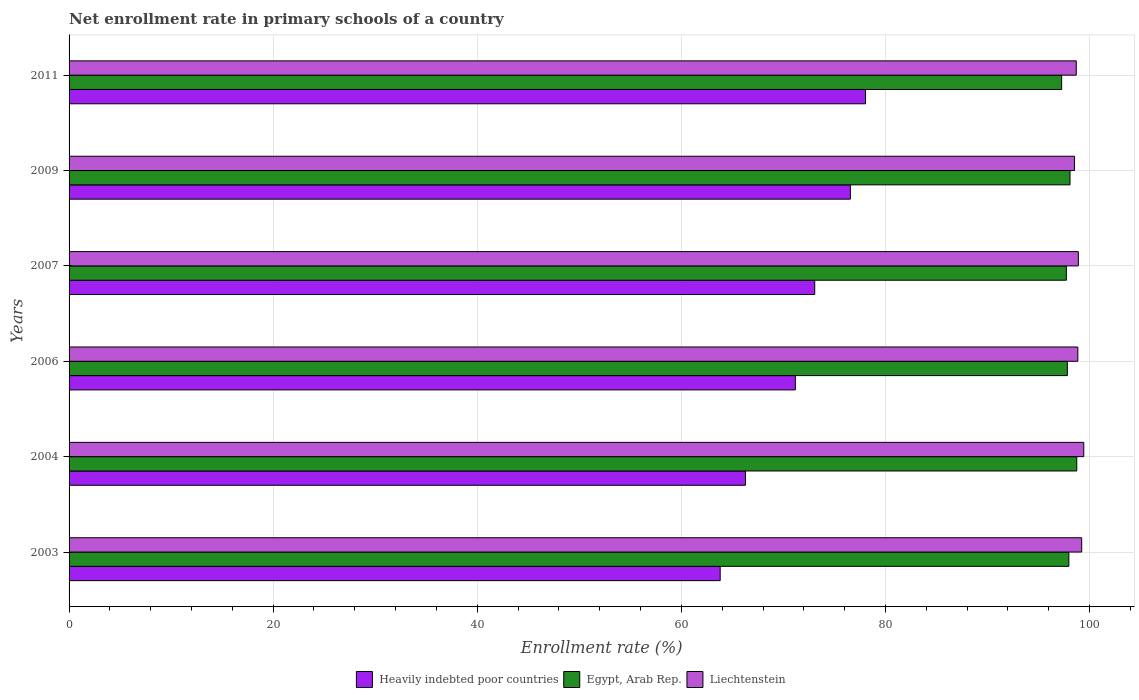How many groups of bars are there?
Your answer should be very brief. 6. How many bars are there on the 1st tick from the top?
Your response must be concise. 3. What is the label of the 6th group of bars from the top?
Offer a very short reply. 2003. What is the enrollment rate in primary schools in Egypt, Arab Rep. in 2007?
Your response must be concise. 97.73. Across all years, what is the maximum enrollment rate in primary schools in Egypt, Arab Rep.?
Keep it short and to the point. 98.75. Across all years, what is the minimum enrollment rate in primary schools in Liechtenstein?
Your answer should be very brief. 98.52. What is the total enrollment rate in primary schools in Liechtenstein in the graph?
Offer a very short reply. 593.63. What is the difference between the enrollment rate in primary schools in Liechtenstein in 2003 and that in 2009?
Your answer should be very brief. 0.71. What is the difference between the enrollment rate in primary schools in Liechtenstein in 2007 and the enrollment rate in primary schools in Heavily indebted poor countries in 2003?
Offer a very short reply. 35.1. What is the average enrollment rate in primary schools in Liechtenstein per year?
Offer a terse response. 98.94. In the year 2003, what is the difference between the enrollment rate in primary schools in Heavily indebted poor countries and enrollment rate in primary schools in Liechtenstein?
Make the answer very short. -35.42. What is the ratio of the enrollment rate in primary schools in Egypt, Arab Rep. in 2006 to that in 2011?
Make the answer very short. 1.01. Is the enrollment rate in primary schools in Heavily indebted poor countries in 2003 less than that in 2011?
Offer a terse response. Yes. What is the difference between the highest and the second highest enrollment rate in primary schools in Liechtenstein?
Keep it short and to the point. 0.2. What is the difference between the highest and the lowest enrollment rate in primary schools in Liechtenstein?
Provide a short and direct response. 0.91. In how many years, is the enrollment rate in primary schools in Egypt, Arab Rep. greater than the average enrollment rate in primary schools in Egypt, Arab Rep. taken over all years?
Make the answer very short. 3. Is the sum of the enrollment rate in primary schools in Liechtenstein in 2004 and 2007 greater than the maximum enrollment rate in primary schools in Egypt, Arab Rep. across all years?
Offer a very short reply. Yes. What does the 2nd bar from the top in 2009 represents?
Give a very brief answer. Egypt, Arab Rep. What does the 1st bar from the bottom in 2009 represents?
Keep it short and to the point. Heavily indebted poor countries. Is it the case that in every year, the sum of the enrollment rate in primary schools in Heavily indebted poor countries and enrollment rate in primary schools in Egypt, Arab Rep. is greater than the enrollment rate in primary schools in Liechtenstein?
Offer a terse response. Yes. How many bars are there?
Your answer should be compact. 18. How many years are there in the graph?
Provide a succinct answer. 6. What is the difference between two consecutive major ticks on the X-axis?
Your answer should be compact. 20. Are the values on the major ticks of X-axis written in scientific E-notation?
Your response must be concise. No. Does the graph contain any zero values?
Offer a very short reply. No. Where does the legend appear in the graph?
Your answer should be compact. Bottom center. How many legend labels are there?
Provide a short and direct response. 3. How are the legend labels stacked?
Your response must be concise. Horizontal. What is the title of the graph?
Offer a terse response. Net enrollment rate in primary schools of a country. Does "Latin America(developing only)" appear as one of the legend labels in the graph?
Make the answer very short. No. What is the label or title of the X-axis?
Ensure brevity in your answer.  Enrollment rate (%). What is the Enrollment rate (%) in Heavily indebted poor countries in 2003?
Offer a very short reply. 63.81. What is the Enrollment rate (%) in Egypt, Arab Rep. in 2003?
Offer a terse response. 97.97. What is the Enrollment rate (%) in Liechtenstein in 2003?
Provide a succinct answer. 99.23. What is the Enrollment rate (%) of Heavily indebted poor countries in 2004?
Offer a very short reply. 66.28. What is the Enrollment rate (%) in Egypt, Arab Rep. in 2004?
Offer a terse response. 98.75. What is the Enrollment rate (%) in Liechtenstein in 2004?
Provide a short and direct response. 99.43. What is the Enrollment rate (%) in Heavily indebted poor countries in 2006?
Offer a terse response. 71.17. What is the Enrollment rate (%) in Egypt, Arab Rep. in 2006?
Offer a terse response. 97.83. What is the Enrollment rate (%) of Liechtenstein in 2006?
Ensure brevity in your answer.  98.85. What is the Enrollment rate (%) in Heavily indebted poor countries in 2007?
Give a very brief answer. 73.07. What is the Enrollment rate (%) of Egypt, Arab Rep. in 2007?
Ensure brevity in your answer.  97.73. What is the Enrollment rate (%) in Liechtenstein in 2007?
Offer a terse response. 98.9. What is the Enrollment rate (%) of Heavily indebted poor countries in 2009?
Make the answer very short. 76.56. What is the Enrollment rate (%) of Egypt, Arab Rep. in 2009?
Provide a succinct answer. 98.09. What is the Enrollment rate (%) of Liechtenstein in 2009?
Ensure brevity in your answer.  98.52. What is the Enrollment rate (%) of Heavily indebted poor countries in 2011?
Offer a terse response. 78.05. What is the Enrollment rate (%) in Egypt, Arab Rep. in 2011?
Offer a terse response. 97.27. What is the Enrollment rate (%) in Liechtenstein in 2011?
Ensure brevity in your answer.  98.7. Across all years, what is the maximum Enrollment rate (%) of Heavily indebted poor countries?
Offer a very short reply. 78.05. Across all years, what is the maximum Enrollment rate (%) of Egypt, Arab Rep.?
Give a very brief answer. 98.75. Across all years, what is the maximum Enrollment rate (%) of Liechtenstein?
Provide a short and direct response. 99.43. Across all years, what is the minimum Enrollment rate (%) in Heavily indebted poor countries?
Your response must be concise. 63.81. Across all years, what is the minimum Enrollment rate (%) of Egypt, Arab Rep.?
Give a very brief answer. 97.27. Across all years, what is the minimum Enrollment rate (%) of Liechtenstein?
Your answer should be compact. 98.52. What is the total Enrollment rate (%) in Heavily indebted poor countries in the graph?
Your response must be concise. 428.93. What is the total Enrollment rate (%) of Egypt, Arab Rep. in the graph?
Your answer should be very brief. 587.62. What is the total Enrollment rate (%) in Liechtenstein in the graph?
Provide a succinct answer. 593.63. What is the difference between the Enrollment rate (%) in Heavily indebted poor countries in 2003 and that in 2004?
Your answer should be very brief. -2.48. What is the difference between the Enrollment rate (%) in Egypt, Arab Rep. in 2003 and that in 2004?
Provide a short and direct response. -0.78. What is the difference between the Enrollment rate (%) in Liechtenstein in 2003 and that in 2004?
Provide a succinct answer. -0.2. What is the difference between the Enrollment rate (%) in Heavily indebted poor countries in 2003 and that in 2006?
Give a very brief answer. -7.37. What is the difference between the Enrollment rate (%) in Egypt, Arab Rep. in 2003 and that in 2006?
Your answer should be compact. 0.15. What is the difference between the Enrollment rate (%) in Liechtenstein in 2003 and that in 2006?
Offer a terse response. 0.38. What is the difference between the Enrollment rate (%) of Heavily indebted poor countries in 2003 and that in 2007?
Offer a very short reply. -9.27. What is the difference between the Enrollment rate (%) of Egypt, Arab Rep. in 2003 and that in 2007?
Provide a succinct answer. 0.24. What is the difference between the Enrollment rate (%) of Liechtenstein in 2003 and that in 2007?
Your answer should be very brief. 0.33. What is the difference between the Enrollment rate (%) of Heavily indebted poor countries in 2003 and that in 2009?
Make the answer very short. -12.76. What is the difference between the Enrollment rate (%) in Egypt, Arab Rep. in 2003 and that in 2009?
Your answer should be compact. -0.11. What is the difference between the Enrollment rate (%) in Liechtenstein in 2003 and that in 2009?
Offer a terse response. 0.71. What is the difference between the Enrollment rate (%) of Heavily indebted poor countries in 2003 and that in 2011?
Offer a very short reply. -14.24. What is the difference between the Enrollment rate (%) in Egypt, Arab Rep. in 2003 and that in 2011?
Provide a succinct answer. 0.71. What is the difference between the Enrollment rate (%) in Liechtenstein in 2003 and that in 2011?
Offer a terse response. 0.53. What is the difference between the Enrollment rate (%) of Heavily indebted poor countries in 2004 and that in 2006?
Your response must be concise. -4.89. What is the difference between the Enrollment rate (%) of Egypt, Arab Rep. in 2004 and that in 2006?
Make the answer very short. 0.92. What is the difference between the Enrollment rate (%) of Liechtenstein in 2004 and that in 2006?
Your answer should be very brief. 0.58. What is the difference between the Enrollment rate (%) of Heavily indebted poor countries in 2004 and that in 2007?
Offer a terse response. -6.79. What is the difference between the Enrollment rate (%) in Egypt, Arab Rep. in 2004 and that in 2007?
Ensure brevity in your answer.  1.02. What is the difference between the Enrollment rate (%) of Liechtenstein in 2004 and that in 2007?
Give a very brief answer. 0.53. What is the difference between the Enrollment rate (%) in Heavily indebted poor countries in 2004 and that in 2009?
Make the answer very short. -10.28. What is the difference between the Enrollment rate (%) in Egypt, Arab Rep. in 2004 and that in 2009?
Your answer should be compact. 0.66. What is the difference between the Enrollment rate (%) of Liechtenstein in 2004 and that in 2009?
Keep it short and to the point. 0.91. What is the difference between the Enrollment rate (%) in Heavily indebted poor countries in 2004 and that in 2011?
Offer a very short reply. -11.77. What is the difference between the Enrollment rate (%) of Egypt, Arab Rep. in 2004 and that in 2011?
Ensure brevity in your answer.  1.48. What is the difference between the Enrollment rate (%) in Liechtenstein in 2004 and that in 2011?
Give a very brief answer. 0.73. What is the difference between the Enrollment rate (%) of Heavily indebted poor countries in 2006 and that in 2007?
Give a very brief answer. -1.9. What is the difference between the Enrollment rate (%) in Egypt, Arab Rep. in 2006 and that in 2007?
Make the answer very short. 0.1. What is the difference between the Enrollment rate (%) in Liechtenstein in 2006 and that in 2007?
Give a very brief answer. -0.05. What is the difference between the Enrollment rate (%) of Heavily indebted poor countries in 2006 and that in 2009?
Provide a succinct answer. -5.39. What is the difference between the Enrollment rate (%) of Egypt, Arab Rep. in 2006 and that in 2009?
Your answer should be compact. -0.26. What is the difference between the Enrollment rate (%) in Liechtenstein in 2006 and that in 2009?
Offer a terse response. 0.33. What is the difference between the Enrollment rate (%) in Heavily indebted poor countries in 2006 and that in 2011?
Your answer should be compact. -6.87. What is the difference between the Enrollment rate (%) of Egypt, Arab Rep. in 2006 and that in 2011?
Provide a succinct answer. 0.56. What is the difference between the Enrollment rate (%) in Liechtenstein in 2006 and that in 2011?
Your answer should be very brief. 0.15. What is the difference between the Enrollment rate (%) of Heavily indebted poor countries in 2007 and that in 2009?
Provide a succinct answer. -3.49. What is the difference between the Enrollment rate (%) of Egypt, Arab Rep. in 2007 and that in 2009?
Offer a terse response. -0.36. What is the difference between the Enrollment rate (%) of Liechtenstein in 2007 and that in 2009?
Your response must be concise. 0.38. What is the difference between the Enrollment rate (%) in Heavily indebted poor countries in 2007 and that in 2011?
Give a very brief answer. -4.98. What is the difference between the Enrollment rate (%) in Egypt, Arab Rep. in 2007 and that in 2011?
Ensure brevity in your answer.  0.46. What is the difference between the Enrollment rate (%) of Liechtenstein in 2007 and that in 2011?
Provide a short and direct response. 0.2. What is the difference between the Enrollment rate (%) in Heavily indebted poor countries in 2009 and that in 2011?
Keep it short and to the point. -1.48. What is the difference between the Enrollment rate (%) of Egypt, Arab Rep. in 2009 and that in 2011?
Your answer should be very brief. 0.82. What is the difference between the Enrollment rate (%) in Liechtenstein in 2009 and that in 2011?
Offer a very short reply. -0.18. What is the difference between the Enrollment rate (%) in Heavily indebted poor countries in 2003 and the Enrollment rate (%) in Egypt, Arab Rep. in 2004?
Offer a terse response. -34.94. What is the difference between the Enrollment rate (%) of Heavily indebted poor countries in 2003 and the Enrollment rate (%) of Liechtenstein in 2004?
Your answer should be very brief. -35.63. What is the difference between the Enrollment rate (%) in Egypt, Arab Rep. in 2003 and the Enrollment rate (%) in Liechtenstein in 2004?
Provide a succinct answer. -1.46. What is the difference between the Enrollment rate (%) of Heavily indebted poor countries in 2003 and the Enrollment rate (%) of Egypt, Arab Rep. in 2006?
Make the answer very short. -34.02. What is the difference between the Enrollment rate (%) of Heavily indebted poor countries in 2003 and the Enrollment rate (%) of Liechtenstein in 2006?
Keep it short and to the point. -35.05. What is the difference between the Enrollment rate (%) of Egypt, Arab Rep. in 2003 and the Enrollment rate (%) of Liechtenstein in 2006?
Your answer should be compact. -0.88. What is the difference between the Enrollment rate (%) of Heavily indebted poor countries in 2003 and the Enrollment rate (%) of Egypt, Arab Rep. in 2007?
Your response must be concise. -33.92. What is the difference between the Enrollment rate (%) of Heavily indebted poor countries in 2003 and the Enrollment rate (%) of Liechtenstein in 2007?
Ensure brevity in your answer.  -35.1. What is the difference between the Enrollment rate (%) in Egypt, Arab Rep. in 2003 and the Enrollment rate (%) in Liechtenstein in 2007?
Make the answer very short. -0.93. What is the difference between the Enrollment rate (%) of Heavily indebted poor countries in 2003 and the Enrollment rate (%) of Egypt, Arab Rep. in 2009?
Keep it short and to the point. -34.28. What is the difference between the Enrollment rate (%) in Heavily indebted poor countries in 2003 and the Enrollment rate (%) in Liechtenstein in 2009?
Your response must be concise. -34.72. What is the difference between the Enrollment rate (%) in Egypt, Arab Rep. in 2003 and the Enrollment rate (%) in Liechtenstein in 2009?
Provide a short and direct response. -0.55. What is the difference between the Enrollment rate (%) of Heavily indebted poor countries in 2003 and the Enrollment rate (%) of Egypt, Arab Rep. in 2011?
Offer a very short reply. -33.46. What is the difference between the Enrollment rate (%) in Heavily indebted poor countries in 2003 and the Enrollment rate (%) in Liechtenstein in 2011?
Your response must be concise. -34.89. What is the difference between the Enrollment rate (%) in Egypt, Arab Rep. in 2003 and the Enrollment rate (%) in Liechtenstein in 2011?
Your response must be concise. -0.73. What is the difference between the Enrollment rate (%) of Heavily indebted poor countries in 2004 and the Enrollment rate (%) of Egypt, Arab Rep. in 2006?
Your answer should be very brief. -31.54. What is the difference between the Enrollment rate (%) of Heavily indebted poor countries in 2004 and the Enrollment rate (%) of Liechtenstein in 2006?
Keep it short and to the point. -32.57. What is the difference between the Enrollment rate (%) of Egypt, Arab Rep. in 2004 and the Enrollment rate (%) of Liechtenstein in 2006?
Provide a succinct answer. -0.1. What is the difference between the Enrollment rate (%) in Heavily indebted poor countries in 2004 and the Enrollment rate (%) in Egypt, Arab Rep. in 2007?
Keep it short and to the point. -31.45. What is the difference between the Enrollment rate (%) in Heavily indebted poor countries in 2004 and the Enrollment rate (%) in Liechtenstein in 2007?
Make the answer very short. -32.62. What is the difference between the Enrollment rate (%) of Egypt, Arab Rep. in 2004 and the Enrollment rate (%) of Liechtenstein in 2007?
Offer a very short reply. -0.15. What is the difference between the Enrollment rate (%) of Heavily indebted poor countries in 2004 and the Enrollment rate (%) of Egypt, Arab Rep. in 2009?
Ensure brevity in your answer.  -31.8. What is the difference between the Enrollment rate (%) in Heavily indebted poor countries in 2004 and the Enrollment rate (%) in Liechtenstein in 2009?
Make the answer very short. -32.24. What is the difference between the Enrollment rate (%) of Egypt, Arab Rep. in 2004 and the Enrollment rate (%) of Liechtenstein in 2009?
Your response must be concise. 0.23. What is the difference between the Enrollment rate (%) in Heavily indebted poor countries in 2004 and the Enrollment rate (%) in Egypt, Arab Rep. in 2011?
Your response must be concise. -30.99. What is the difference between the Enrollment rate (%) in Heavily indebted poor countries in 2004 and the Enrollment rate (%) in Liechtenstein in 2011?
Offer a very short reply. -32.42. What is the difference between the Enrollment rate (%) of Egypt, Arab Rep. in 2004 and the Enrollment rate (%) of Liechtenstein in 2011?
Your answer should be very brief. 0.05. What is the difference between the Enrollment rate (%) in Heavily indebted poor countries in 2006 and the Enrollment rate (%) in Egypt, Arab Rep. in 2007?
Make the answer very short. -26.56. What is the difference between the Enrollment rate (%) in Heavily indebted poor countries in 2006 and the Enrollment rate (%) in Liechtenstein in 2007?
Offer a very short reply. -27.73. What is the difference between the Enrollment rate (%) of Egypt, Arab Rep. in 2006 and the Enrollment rate (%) of Liechtenstein in 2007?
Make the answer very short. -1.08. What is the difference between the Enrollment rate (%) in Heavily indebted poor countries in 2006 and the Enrollment rate (%) in Egypt, Arab Rep. in 2009?
Your answer should be very brief. -26.91. What is the difference between the Enrollment rate (%) in Heavily indebted poor countries in 2006 and the Enrollment rate (%) in Liechtenstein in 2009?
Give a very brief answer. -27.35. What is the difference between the Enrollment rate (%) in Egypt, Arab Rep. in 2006 and the Enrollment rate (%) in Liechtenstein in 2009?
Ensure brevity in your answer.  -0.7. What is the difference between the Enrollment rate (%) in Heavily indebted poor countries in 2006 and the Enrollment rate (%) in Egypt, Arab Rep. in 2011?
Your answer should be very brief. -26.1. What is the difference between the Enrollment rate (%) of Heavily indebted poor countries in 2006 and the Enrollment rate (%) of Liechtenstein in 2011?
Offer a very short reply. -27.53. What is the difference between the Enrollment rate (%) of Egypt, Arab Rep. in 2006 and the Enrollment rate (%) of Liechtenstein in 2011?
Provide a short and direct response. -0.87. What is the difference between the Enrollment rate (%) in Heavily indebted poor countries in 2007 and the Enrollment rate (%) in Egypt, Arab Rep. in 2009?
Offer a very short reply. -25.02. What is the difference between the Enrollment rate (%) of Heavily indebted poor countries in 2007 and the Enrollment rate (%) of Liechtenstein in 2009?
Offer a terse response. -25.45. What is the difference between the Enrollment rate (%) of Egypt, Arab Rep. in 2007 and the Enrollment rate (%) of Liechtenstein in 2009?
Offer a very short reply. -0.79. What is the difference between the Enrollment rate (%) in Heavily indebted poor countries in 2007 and the Enrollment rate (%) in Egypt, Arab Rep. in 2011?
Your answer should be compact. -24.2. What is the difference between the Enrollment rate (%) of Heavily indebted poor countries in 2007 and the Enrollment rate (%) of Liechtenstein in 2011?
Your response must be concise. -25.63. What is the difference between the Enrollment rate (%) in Egypt, Arab Rep. in 2007 and the Enrollment rate (%) in Liechtenstein in 2011?
Your answer should be compact. -0.97. What is the difference between the Enrollment rate (%) in Heavily indebted poor countries in 2009 and the Enrollment rate (%) in Egypt, Arab Rep. in 2011?
Offer a very short reply. -20.7. What is the difference between the Enrollment rate (%) in Heavily indebted poor countries in 2009 and the Enrollment rate (%) in Liechtenstein in 2011?
Give a very brief answer. -22.13. What is the difference between the Enrollment rate (%) of Egypt, Arab Rep. in 2009 and the Enrollment rate (%) of Liechtenstein in 2011?
Keep it short and to the point. -0.61. What is the average Enrollment rate (%) of Heavily indebted poor countries per year?
Your answer should be very brief. 71.49. What is the average Enrollment rate (%) in Egypt, Arab Rep. per year?
Offer a very short reply. 97.94. What is the average Enrollment rate (%) of Liechtenstein per year?
Ensure brevity in your answer.  98.94. In the year 2003, what is the difference between the Enrollment rate (%) of Heavily indebted poor countries and Enrollment rate (%) of Egypt, Arab Rep.?
Make the answer very short. -34.17. In the year 2003, what is the difference between the Enrollment rate (%) in Heavily indebted poor countries and Enrollment rate (%) in Liechtenstein?
Give a very brief answer. -35.42. In the year 2003, what is the difference between the Enrollment rate (%) in Egypt, Arab Rep. and Enrollment rate (%) in Liechtenstein?
Your answer should be very brief. -1.26. In the year 2004, what is the difference between the Enrollment rate (%) of Heavily indebted poor countries and Enrollment rate (%) of Egypt, Arab Rep.?
Your answer should be very brief. -32.47. In the year 2004, what is the difference between the Enrollment rate (%) of Heavily indebted poor countries and Enrollment rate (%) of Liechtenstein?
Your answer should be very brief. -33.15. In the year 2004, what is the difference between the Enrollment rate (%) in Egypt, Arab Rep. and Enrollment rate (%) in Liechtenstein?
Your answer should be very brief. -0.68. In the year 2006, what is the difference between the Enrollment rate (%) of Heavily indebted poor countries and Enrollment rate (%) of Egypt, Arab Rep.?
Your answer should be compact. -26.65. In the year 2006, what is the difference between the Enrollment rate (%) in Heavily indebted poor countries and Enrollment rate (%) in Liechtenstein?
Offer a terse response. -27.68. In the year 2006, what is the difference between the Enrollment rate (%) in Egypt, Arab Rep. and Enrollment rate (%) in Liechtenstein?
Your response must be concise. -1.03. In the year 2007, what is the difference between the Enrollment rate (%) of Heavily indebted poor countries and Enrollment rate (%) of Egypt, Arab Rep.?
Ensure brevity in your answer.  -24.66. In the year 2007, what is the difference between the Enrollment rate (%) of Heavily indebted poor countries and Enrollment rate (%) of Liechtenstein?
Your response must be concise. -25.83. In the year 2007, what is the difference between the Enrollment rate (%) of Egypt, Arab Rep. and Enrollment rate (%) of Liechtenstein?
Your response must be concise. -1.18. In the year 2009, what is the difference between the Enrollment rate (%) in Heavily indebted poor countries and Enrollment rate (%) in Egypt, Arab Rep.?
Provide a short and direct response. -21.52. In the year 2009, what is the difference between the Enrollment rate (%) in Heavily indebted poor countries and Enrollment rate (%) in Liechtenstein?
Ensure brevity in your answer.  -21.96. In the year 2009, what is the difference between the Enrollment rate (%) of Egypt, Arab Rep. and Enrollment rate (%) of Liechtenstein?
Make the answer very short. -0.44. In the year 2011, what is the difference between the Enrollment rate (%) in Heavily indebted poor countries and Enrollment rate (%) in Egypt, Arab Rep.?
Offer a terse response. -19.22. In the year 2011, what is the difference between the Enrollment rate (%) of Heavily indebted poor countries and Enrollment rate (%) of Liechtenstein?
Make the answer very short. -20.65. In the year 2011, what is the difference between the Enrollment rate (%) in Egypt, Arab Rep. and Enrollment rate (%) in Liechtenstein?
Ensure brevity in your answer.  -1.43. What is the ratio of the Enrollment rate (%) in Heavily indebted poor countries in 2003 to that in 2004?
Your answer should be compact. 0.96. What is the ratio of the Enrollment rate (%) in Liechtenstein in 2003 to that in 2004?
Your answer should be very brief. 1. What is the ratio of the Enrollment rate (%) in Heavily indebted poor countries in 2003 to that in 2006?
Your answer should be compact. 0.9. What is the ratio of the Enrollment rate (%) in Liechtenstein in 2003 to that in 2006?
Your answer should be compact. 1. What is the ratio of the Enrollment rate (%) of Heavily indebted poor countries in 2003 to that in 2007?
Offer a terse response. 0.87. What is the ratio of the Enrollment rate (%) in Heavily indebted poor countries in 2003 to that in 2009?
Provide a short and direct response. 0.83. What is the ratio of the Enrollment rate (%) of Heavily indebted poor countries in 2003 to that in 2011?
Ensure brevity in your answer.  0.82. What is the ratio of the Enrollment rate (%) in Egypt, Arab Rep. in 2003 to that in 2011?
Make the answer very short. 1.01. What is the ratio of the Enrollment rate (%) in Liechtenstein in 2003 to that in 2011?
Keep it short and to the point. 1.01. What is the ratio of the Enrollment rate (%) of Heavily indebted poor countries in 2004 to that in 2006?
Your response must be concise. 0.93. What is the ratio of the Enrollment rate (%) in Egypt, Arab Rep. in 2004 to that in 2006?
Keep it short and to the point. 1.01. What is the ratio of the Enrollment rate (%) of Liechtenstein in 2004 to that in 2006?
Your answer should be compact. 1.01. What is the ratio of the Enrollment rate (%) of Heavily indebted poor countries in 2004 to that in 2007?
Your answer should be compact. 0.91. What is the ratio of the Enrollment rate (%) in Egypt, Arab Rep. in 2004 to that in 2007?
Give a very brief answer. 1.01. What is the ratio of the Enrollment rate (%) in Liechtenstein in 2004 to that in 2007?
Your answer should be very brief. 1.01. What is the ratio of the Enrollment rate (%) of Heavily indebted poor countries in 2004 to that in 2009?
Give a very brief answer. 0.87. What is the ratio of the Enrollment rate (%) in Egypt, Arab Rep. in 2004 to that in 2009?
Provide a succinct answer. 1.01. What is the ratio of the Enrollment rate (%) of Liechtenstein in 2004 to that in 2009?
Give a very brief answer. 1.01. What is the ratio of the Enrollment rate (%) of Heavily indebted poor countries in 2004 to that in 2011?
Provide a short and direct response. 0.85. What is the ratio of the Enrollment rate (%) of Egypt, Arab Rep. in 2004 to that in 2011?
Keep it short and to the point. 1.02. What is the ratio of the Enrollment rate (%) in Liechtenstein in 2004 to that in 2011?
Give a very brief answer. 1.01. What is the ratio of the Enrollment rate (%) in Heavily indebted poor countries in 2006 to that in 2007?
Keep it short and to the point. 0.97. What is the ratio of the Enrollment rate (%) in Egypt, Arab Rep. in 2006 to that in 2007?
Make the answer very short. 1. What is the ratio of the Enrollment rate (%) in Heavily indebted poor countries in 2006 to that in 2009?
Make the answer very short. 0.93. What is the ratio of the Enrollment rate (%) in Heavily indebted poor countries in 2006 to that in 2011?
Your response must be concise. 0.91. What is the ratio of the Enrollment rate (%) of Egypt, Arab Rep. in 2006 to that in 2011?
Offer a terse response. 1.01. What is the ratio of the Enrollment rate (%) in Liechtenstein in 2006 to that in 2011?
Keep it short and to the point. 1. What is the ratio of the Enrollment rate (%) in Heavily indebted poor countries in 2007 to that in 2009?
Keep it short and to the point. 0.95. What is the ratio of the Enrollment rate (%) of Liechtenstein in 2007 to that in 2009?
Offer a terse response. 1. What is the ratio of the Enrollment rate (%) of Heavily indebted poor countries in 2007 to that in 2011?
Ensure brevity in your answer.  0.94. What is the ratio of the Enrollment rate (%) of Egypt, Arab Rep. in 2007 to that in 2011?
Offer a terse response. 1. What is the ratio of the Enrollment rate (%) of Egypt, Arab Rep. in 2009 to that in 2011?
Give a very brief answer. 1.01. What is the difference between the highest and the second highest Enrollment rate (%) of Heavily indebted poor countries?
Offer a very short reply. 1.48. What is the difference between the highest and the second highest Enrollment rate (%) in Egypt, Arab Rep.?
Your response must be concise. 0.66. What is the difference between the highest and the second highest Enrollment rate (%) of Liechtenstein?
Offer a very short reply. 0.2. What is the difference between the highest and the lowest Enrollment rate (%) in Heavily indebted poor countries?
Offer a very short reply. 14.24. What is the difference between the highest and the lowest Enrollment rate (%) of Egypt, Arab Rep.?
Keep it short and to the point. 1.48. What is the difference between the highest and the lowest Enrollment rate (%) of Liechtenstein?
Make the answer very short. 0.91. 